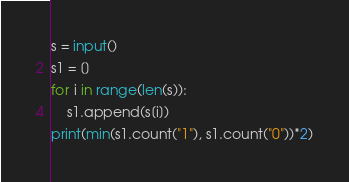<code> <loc_0><loc_0><loc_500><loc_500><_Python_>s = input()
s1 = []
for i in range(len(s)):
    s1.append(s[i])
print(min(s1.count("1"), s1.count("0"))*2)</code> 